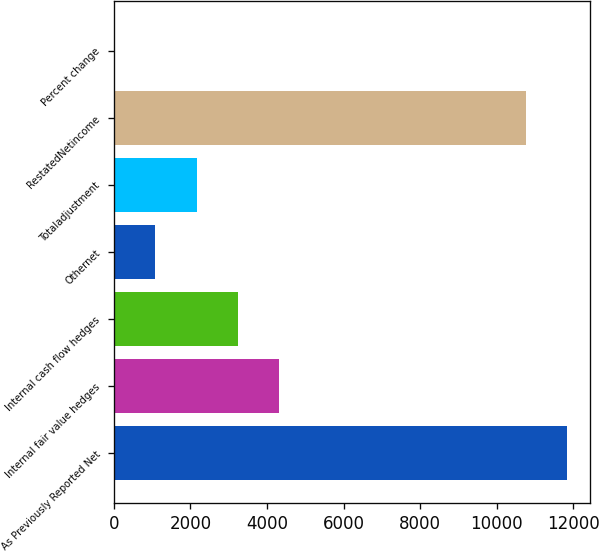Convert chart. <chart><loc_0><loc_0><loc_500><loc_500><bar_chart><fcel>As Previously Reported Net<fcel>Internal fair value hedges<fcel>Internal cash flow hedges<fcel>Othernet<fcel>Totaladjustment<fcel>RestatedNetincome<fcel>Percent change<nl><fcel>11843<fcel>4324.3<fcel>3243.35<fcel>1081.45<fcel>2162.4<fcel>10762<fcel>0.5<nl></chart> 